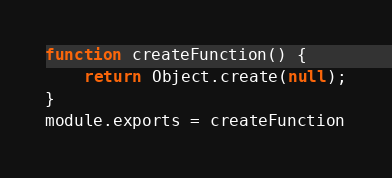<code> <loc_0><loc_0><loc_500><loc_500><_JavaScript_>function createFunction() {
    return Object.create(null);
}
module.exports = createFunction</code> 